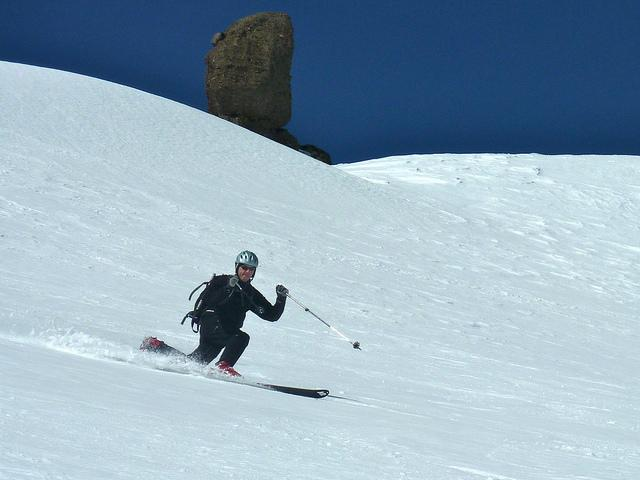Why is the man wearing the silver helmet?

Choices:
A) for halloween
B) safety
C) for amusement
D) style safety 